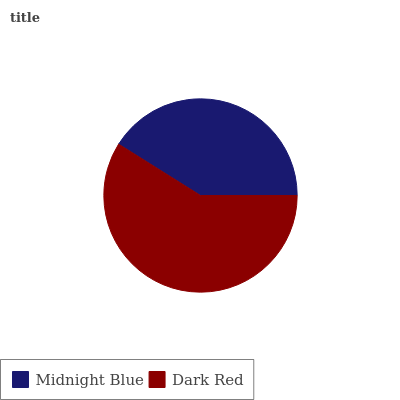Is Midnight Blue the minimum?
Answer yes or no. Yes. Is Dark Red the maximum?
Answer yes or no. Yes. Is Dark Red the minimum?
Answer yes or no. No. Is Dark Red greater than Midnight Blue?
Answer yes or no. Yes. Is Midnight Blue less than Dark Red?
Answer yes or no. Yes. Is Midnight Blue greater than Dark Red?
Answer yes or no. No. Is Dark Red less than Midnight Blue?
Answer yes or no. No. Is Dark Red the high median?
Answer yes or no. Yes. Is Midnight Blue the low median?
Answer yes or no. Yes. Is Midnight Blue the high median?
Answer yes or no. No. Is Dark Red the low median?
Answer yes or no. No. 